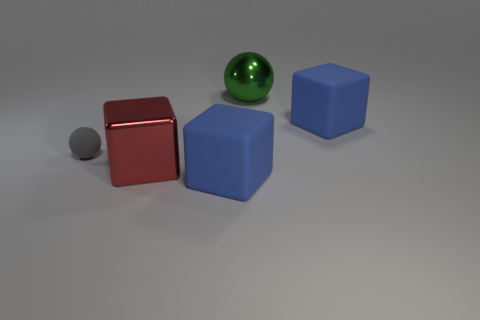Are there any other things that have the same shape as the big green metal object?
Give a very brief answer. Yes. Does the red metallic cube have the same size as the green metallic thing?
Offer a terse response. Yes. Are there any red matte balls of the same size as the green metal thing?
Ensure brevity in your answer.  No. What is the material of the ball right of the tiny gray object?
Offer a very short reply. Metal. What is the color of the thing that is the same material as the large green ball?
Make the answer very short. Red. How many metal things are large things or green objects?
Offer a terse response. 2. There is a red thing that is the same size as the green object; what is its shape?
Offer a very short reply. Cube. How many objects are big blue matte blocks in front of the small gray thing or matte blocks that are behind the gray matte object?
Offer a very short reply. 2. What material is the green object that is the same size as the red metal thing?
Ensure brevity in your answer.  Metal. How many other objects are the same material as the tiny sphere?
Offer a terse response. 2. 